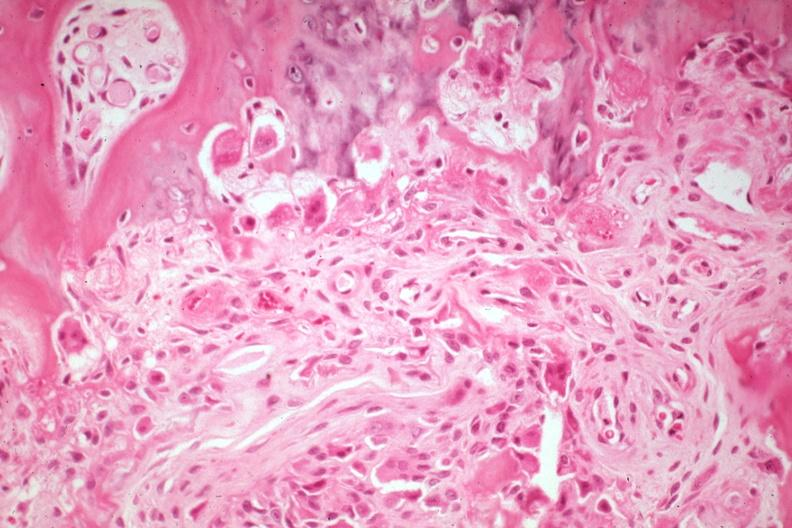what is present?
Answer the question using a single word or phrase. Joints 